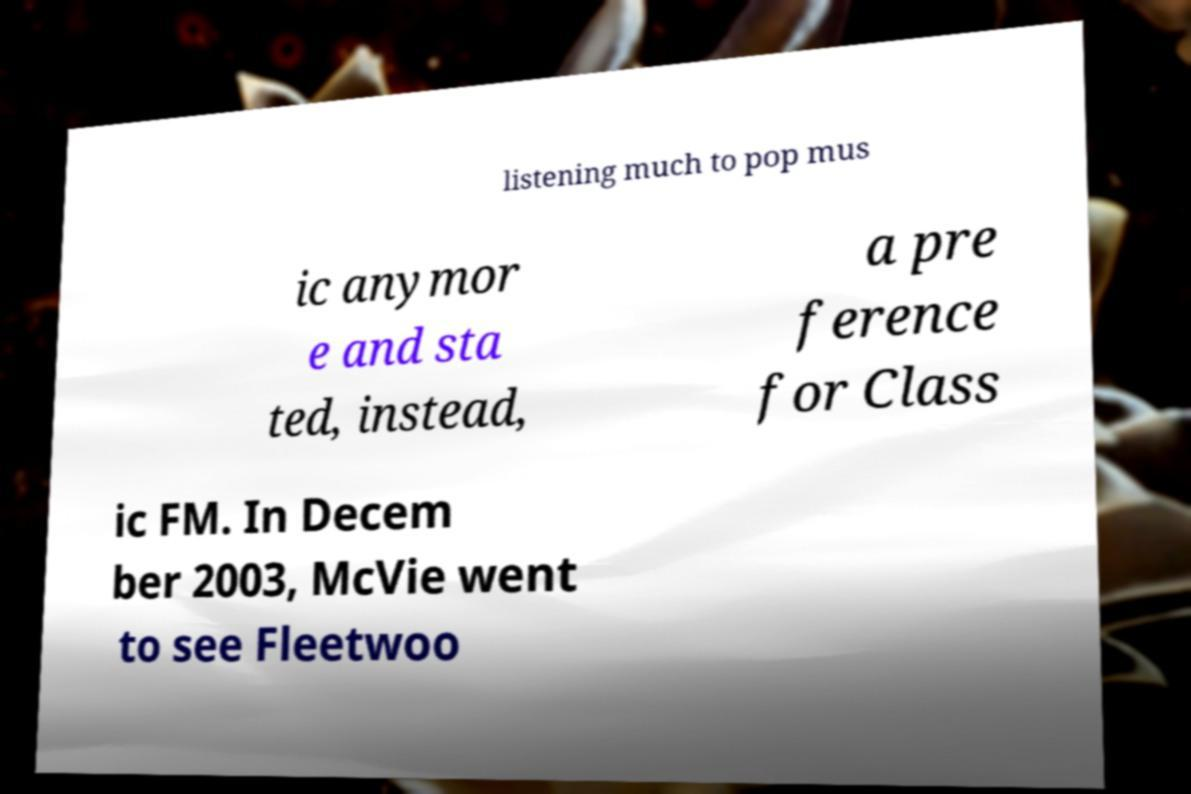Can you accurately transcribe the text from the provided image for me? listening much to pop mus ic anymor e and sta ted, instead, a pre ference for Class ic FM. In Decem ber 2003, McVie went to see Fleetwoo 